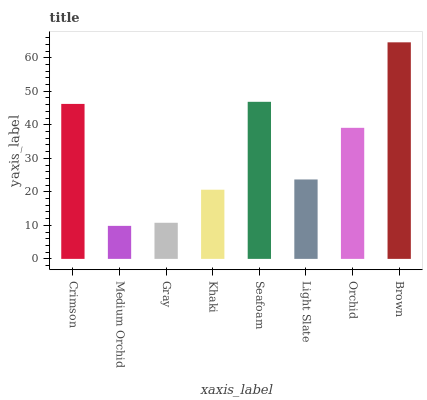Is Gray the minimum?
Answer yes or no. No. Is Gray the maximum?
Answer yes or no. No. Is Gray greater than Medium Orchid?
Answer yes or no. Yes. Is Medium Orchid less than Gray?
Answer yes or no. Yes. Is Medium Orchid greater than Gray?
Answer yes or no. No. Is Gray less than Medium Orchid?
Answer yes or no. No. Is Orchid the high median?
Answer yes or no. Yes. Is Light Slate the low median?
Answer yes or no. Yes. Is Brown the high median?
Answer yes or no. No. Is Khaki the low median?
Answer yes or no. No. 